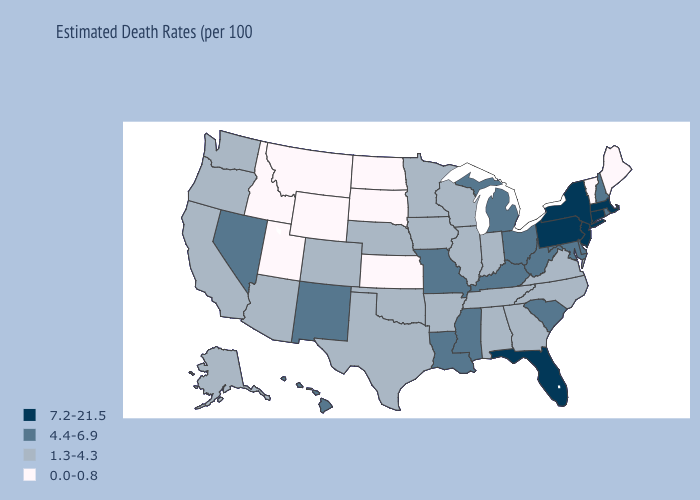Name the states that have a value in the range 4.4-6.9?
Give a very brief answer. Delaware, Hawaii, Kentucky, Louisiana, Maryland, Michigan, Mississippi, Missouri, Nevada, New Hampshire, New Mexico, Ohio, Rhode Island, South Carolina, West Virginia. Does New Mexico have a higher value than Montana?
Write a very short answer. Yes. Does North Dakota have the same value as Montana?
Keep it brief. Yes. What is the value of South Carolina?
Concise answer only. 4.4-6.9. Is the legend a continuous bar?
Answer briefly. No. Does the first symbol in the legend represent the smallest category?
Keep it brief. No. Does New Hampshire have a lower value than Massachusetts?
Short answer required. Yes. Among the states that border Wisconsin , does Michigan have the lowest value?
Answer briefly. No. What is the value of Arkansas?
Be succinct. 1.3-4.3. Does Maryland have a lower value than Massachusetts?
Write a very short answer. Yes. What is the value of Idaho?
Give a very brief answer. 0.0-0.8. Does New Jersey have the lowest value in the Northeast?
Concise answer only. No. Which states hav the highest value in the South?
Concise answer only. Florida. Name the states that have a value in the range 4.4-6.9?
Concise answer only. Delaware, Hawaii, Kentucky, Louisiana, Maryland, Michigan, Mississippi, Missouri, Nevada, New Hampshire, New Mexico, Ohio, Rhode Island, South Carolina, West Virginia. Which states have the lowest value in the USA?
Keep it brief. Idaho, Kansas, Maine, Montana, North Dakota, South Dakota, Utah, Vermont, Wyoming. 